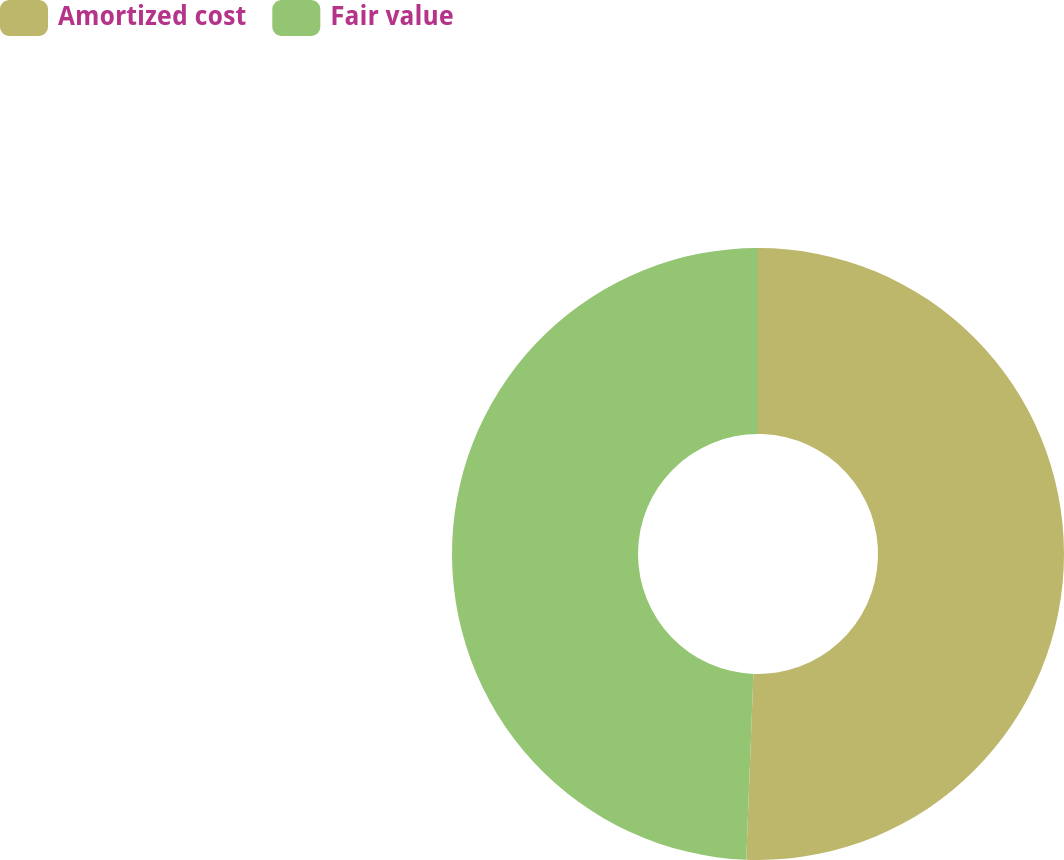<chart> <loc_0><loc_0><loc_500><loc_500><pie_chart><fcel>Amortized cost<fcel>Fair value<nl><fcel>50.61%<fcel>49.39%<nl></chart> 